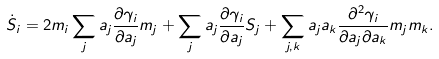Convert formula to latex. <formula><loc_0><loc_0><loc_500><loc_500>\dot { S } _ { i } = 2 m _ { i } \sum _ { j } a _ { j } \frac { \partial \gamma _ { i } } { \partial a _ { j } } m _ { j } + \sum _ { j } a _ { j } \frac { \partial \gamma _ { i } } { \partial a _ { j } } S _ { j } + \sum _ { j , k } a _ { j } a _ { k } \frac { \partial ^ { 2 } \gamma _ { i } } { \partial a _ { j } \partial a _ { k } } m _ { j } m _ { k } .</formula> 